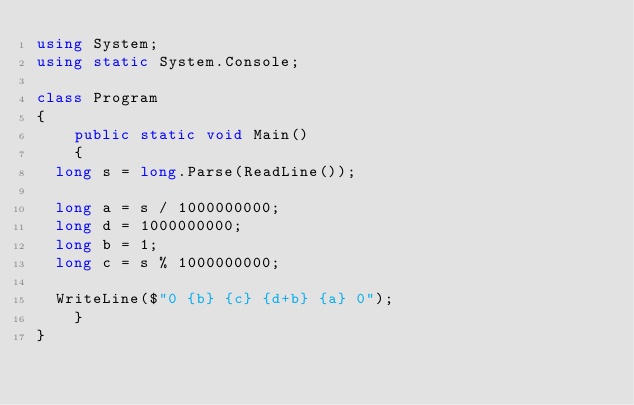<code> <loc_0><loc_0><loc_500><loc_500><_C#_>using System;
using static System.Console;

class Program
{
    public static void Main()
    {
	long s = long.Parse(ReadLine());

	long a = s / 1000000000;
	long d = 1000000000;
	long b = 1;
	long c = s % 1000000000;

	WriteLine($"0 {b} {c} {d+b} {a} 0");
    }
}</code> 